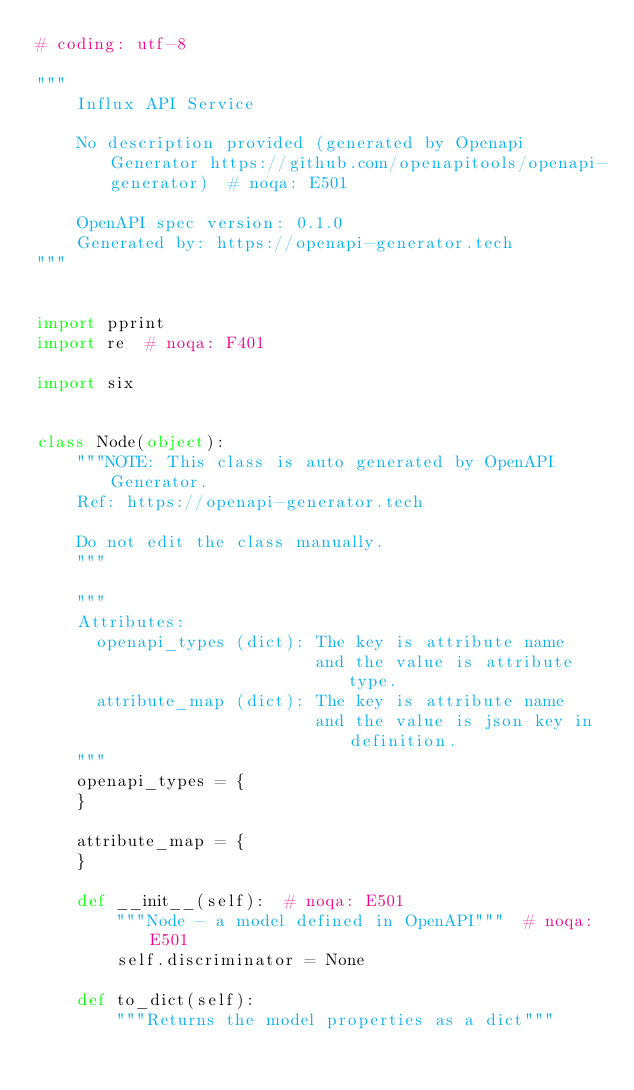Convert code to text. <code><loc_0><loc_0><loc_500><loc_500><_Python_># coding: utf-8

"""
    Influx API Service

    No description provided (generated by Openapi Generator https://github.com/openapitools/openapi-generator)  # noqa: E501

    OpenAPI spec version: 0.1.0
    Generated by: https://openapi-generator.tech
"""


import pprint
import re  # noqa: F401

import six


class Node(object):
    """NOTE: This class is auto generated by OpenAPI Generator.
    Ref: https://openapi-generator.tech

    Do not edit the class manually.
    """

    """
    Attributes:
      openapi_types (dict): The key is attribute name
                            and the value is attribute type.
      attribute_map (dict): The key is attribute name
                            and the value is json key in definition.
    """
    openapi_types = {
    }

    attribute_map = {
    }

    def __init__(self):  # noqa: E501
        """Node - a model defined in OpenAPI"""  # noqa: E501
        self.discriminator = None

    def to_dict(self):
        """Returns the model properties as a dict"""</code> 